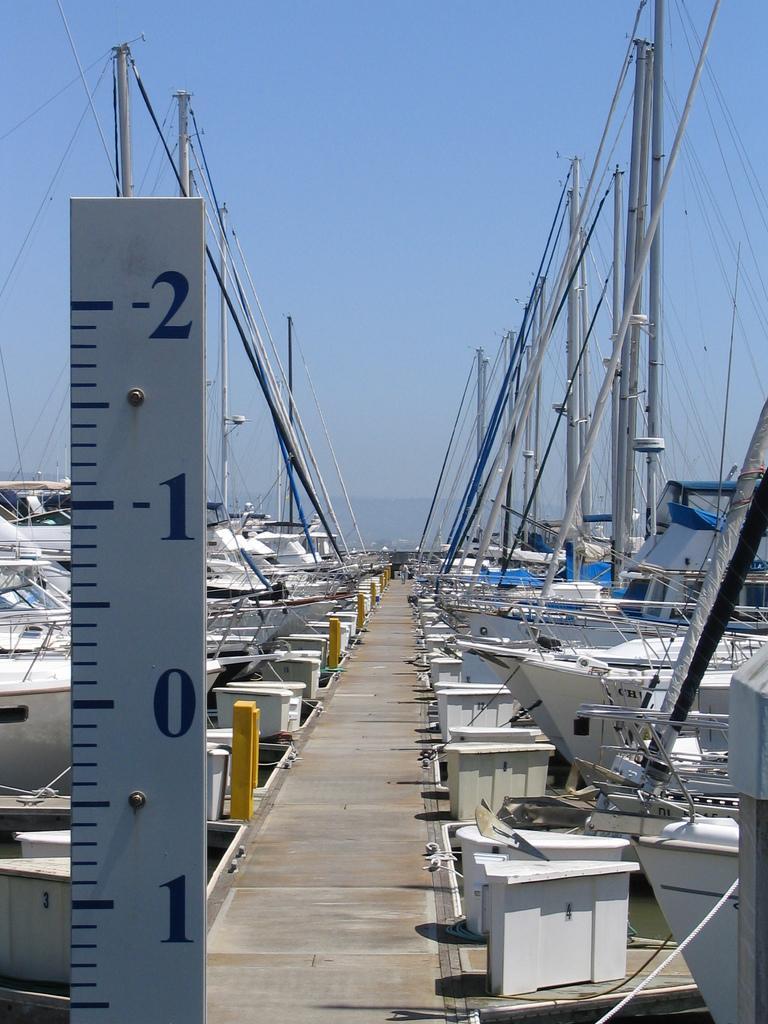How would you summarize this image in a sentence or two? In the center of the image we can see a walk way. On the right and left side of the image there are boats. In the background there is a sea and sky. On the left side there is a scale. 